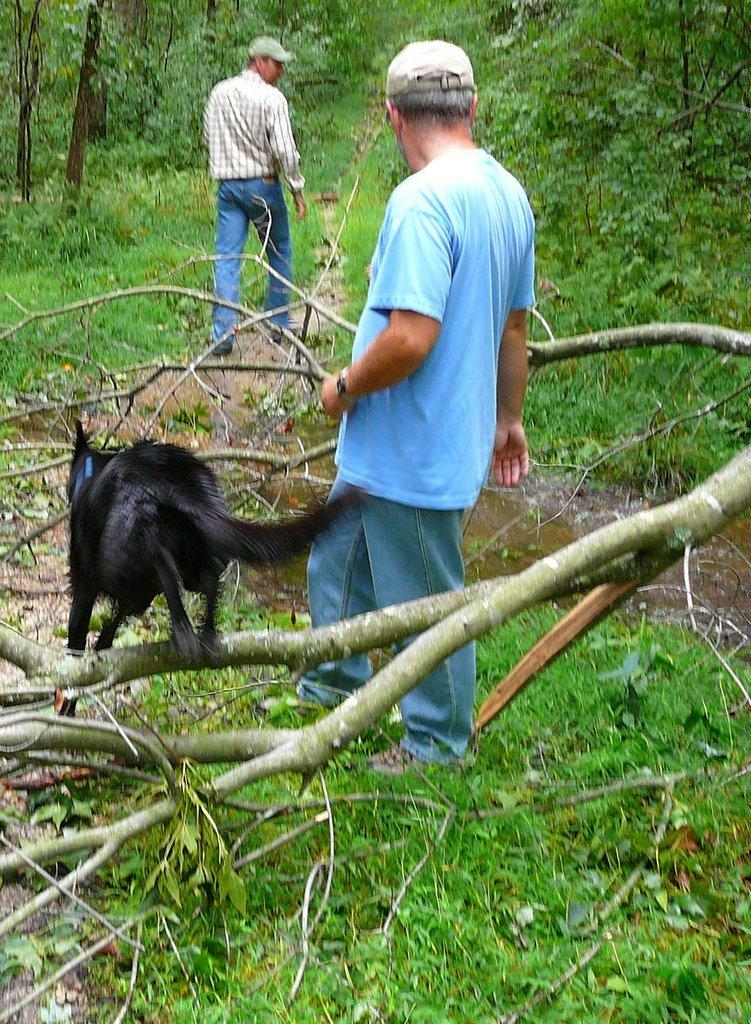How many people are present in the image? There are two persons in the image. What other living creature is present in the image? There is a dog in the image. What type of vegetation can be seen in the image? There are plants, trees, and grass visible in the image. What natural element is visible in the image? Water is visible in the image. What type of cake is being served to the dolls in the image? There are no dolls or cakes present in the image. 